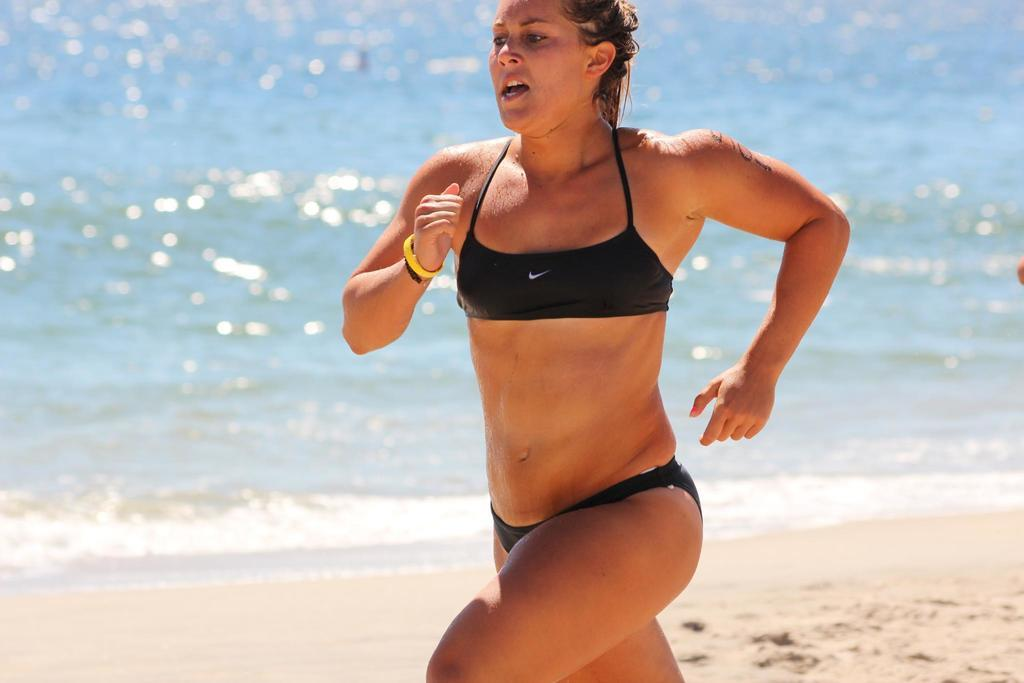What is the lady in the image doing? The lady is running in the image. Where is the lady located in the image? The lady is in the center of the image. What can be seen in the background of the image? There is water and sand visible in the background of the image. What color is the lady's brain in the image? There is no mention of the lady's brain in the image, and therefore no color can be determined. 